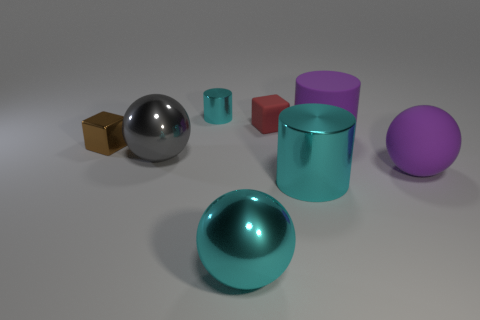Subtract all large purple rubber cylinders. How many cylinders are left? 2 Subtract all cyan spheres. How many spheres are left? 2 Add 1 big rubber balls. How many objects exist? 9 Subtract all purple blocks. Subtract all gray balls. How many blocks are left? 2 Subtract all red blocks. How many blue cylinders are left? 0 Subtract all tiny gray rubber things. Subtract all small red rubber objects. How many objects are left? 7 Add 2 tiny brown metal objects. How many tiny brown metal objects are left? 3 Add 6 big gray objects. How many big gray objects exist? 7 Subtract 0 brown cylinders. How many objects are left? 8 Subtract all cubes. How many objects are left? 6 